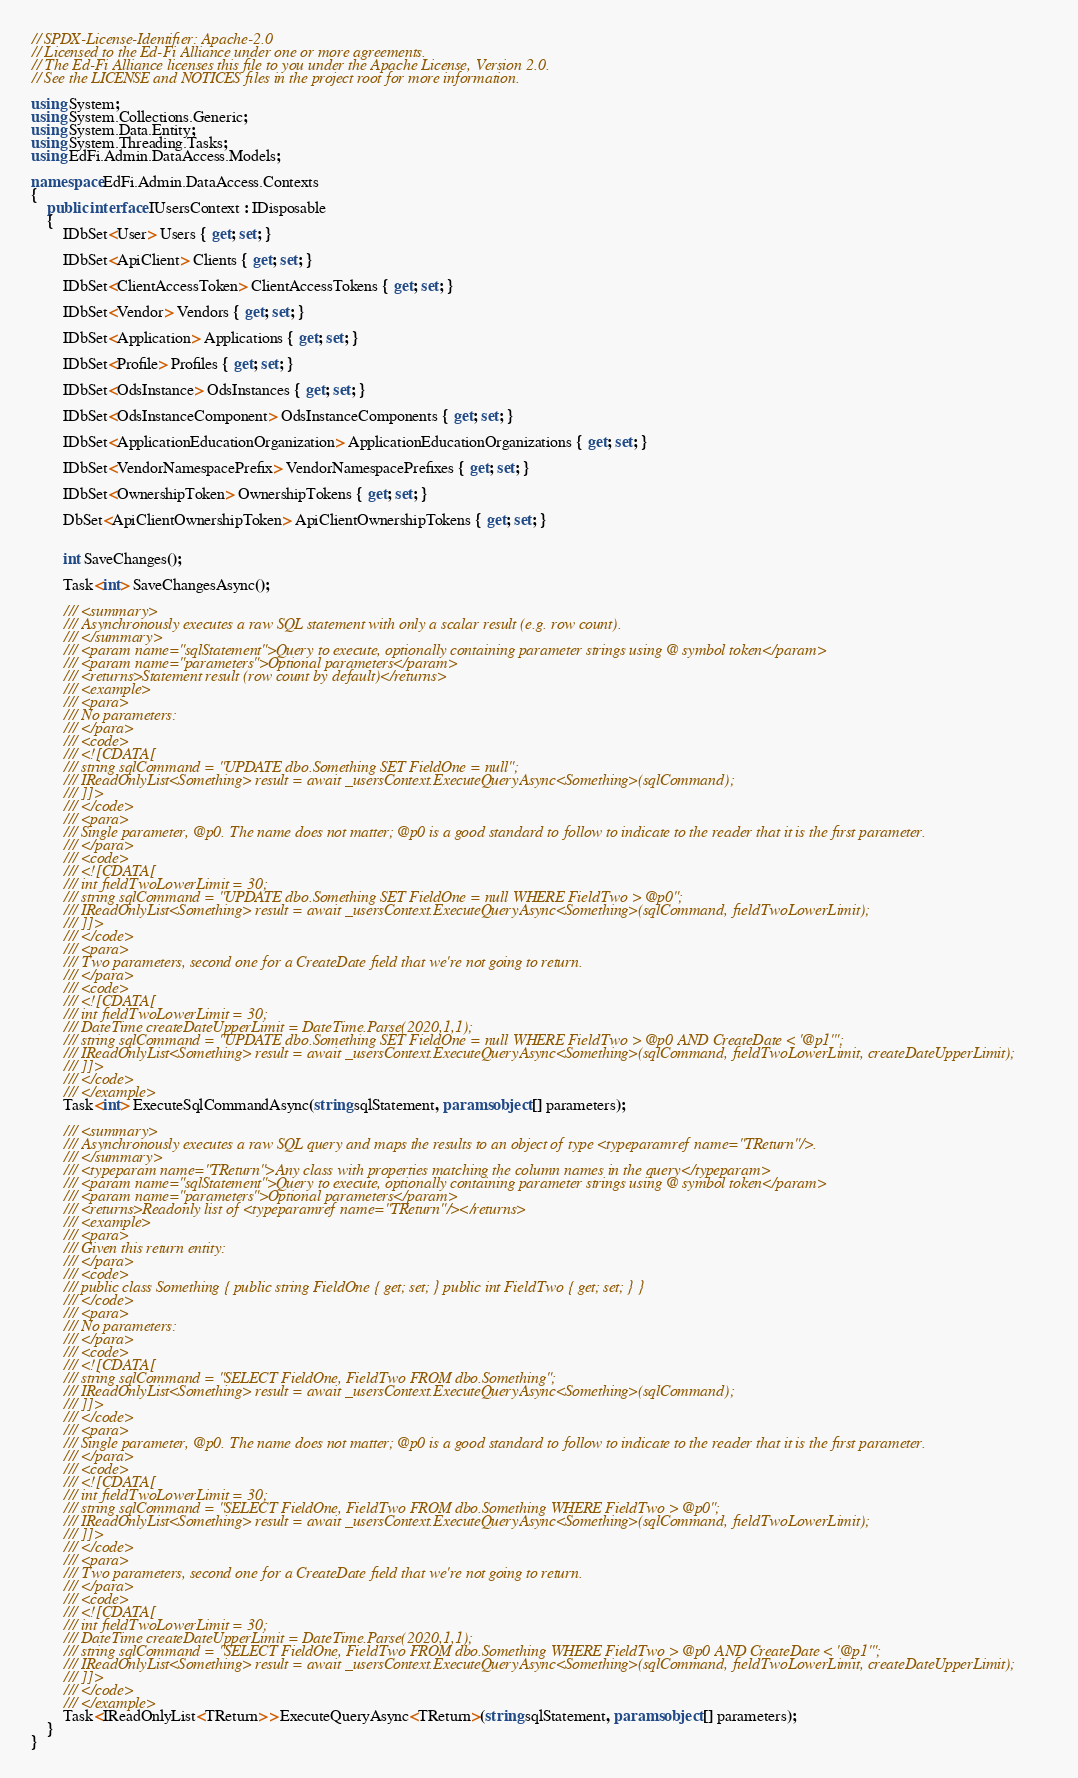Convert code to text. <code><loc_0><loc_0><loc_500><loc_500><_C#_>// SPDX-License-Identifier: Apache-2.0
// Licensed to the Ed-Fi Alliance under one or more agreements.
// The Ed-Fi Alliance licenses this file to you under the Apache License, Version 2.0.
// See the LICENSE and NOTICES files in the project root for more information.

using System;
using System.Collections.Generic;
using System.Data.Entity;
using System.Threading.Tasks;
using EdFi.Admin.DataAccess.Models;

namespace EdFi.Admin.DataAccess.Contexts
{
    public interface IUsersContext : IDisposable
    {
        IDbSet<User> Users { get; set; }

        IDbSet<ApiClient> Clients { get; set; }

        IDbSet<ClientAccessToken> ClientAccessTokens { get; set; }

        IDbSet<Vendor> Vendors { get; set; }

        IDbSet<Application> Applications { get; set; }

        IDbSet<Profile> Profiles { get; set; }

        IDbSet<OdsInstance> OdsInstances { get; set; }

        IDbSet<OdsInstanceComponent> OdsInstanceComponents { get; set; }

        IDbSet<ApplicationEducationOrganization> ApplicationEducationOrganizations { get; set; }

        IDbSet<VendorNamespacePrefix> VendorNamespacePrefixes { get; set; }

        IDbSet<OwnershipToken> OwnershipTokens { get; set; }

        DbSet<ApiClientOwnershipToken> ApiClientOwnershipTokens { get; set; }
        

        int SaveChanges();

        Task<int> SaveChangesAsync();

        /// <summary>
        /// Asynchronously executes a raw SQL statement with only a scalar result (e.g. row count).
        /// </summary>
        /// <param name="sqlStatement">Query to execute, optionally containing parameter strings using @ symbol token</param>
        /// <param name="parameters">Optional parameters</param>
        /// <returns>Statement result (row count by default)</returns>
        /// <example>
        /// <para>
        /// No parameters:
        /// </para>
        /// <code>
        /// <![CDATA[
        /// string sqlCommand = "UPDATE dbo.Something SET FieldOne = null";
        /// IReadOnlyList<Something> result = await _usersContext.ExecuteQueryAsync<Something>(sqlCommand);
        /// ]]>
        /// </code>
        /// <para>
        /// Single parameter, @p0. The name does not matter; @p0 is a good standard to follow to indicate to the reader that it is the first parameter.
        /// </para>
        /// <code>
        /// <![CDATA[
        /// int fieldTwoLowerLimit = 30;
        /// string sqlCommand = "UPDATE dbo.Something SET FieldOne = null WHERE FieldTwo > @p0";
        /// IReadOnlyList<Something> result = await _usersContext.ExecuteQueryAsync<Something>(sqlCommand, fieldTwoLowerLimit);
        /// ]]>
        /// </code>
        /// <para>
        /// Two parameters, second one for a CreateDate field that we're not going to return.
        /// </para>
        /// <code>
        /// <![CDATA[
        /// int fieldTwoLowerLimit = 30;
        /// DateTime createDateUpperLimit = DateTime.Parse(2020,1,1);
        /// string sqlCommand = "UPDATE dbo.Something SET FieldOne = null WHERE FieldTwo > @p0 AND CreateDate < '@p1'";
        /// IReadOnlyList<Something> result = await _usersContext.ExecuteQueryAsync<Something>(sqlCommand, fieldTwoLowerLimit, createDateUpperLimit);
        /// ]]>
        /// </code>
        /// </example>
        Task<int> ExecuteSqlCommandAsync(string sqlStatement, params object[] parameters);

        /// <summary>
        /// Asynchronously executes a raw SQL query and maps the results to an object of type <typeparamref name="TReturn"/>.
        /// </summary>
        /// <typeparam name="TReturn">Any class with properties matching the column names in the query</typeparam>
        /// <param name="sqlStatement">Query to execute, optionally containing parameter strings using @ symbol token</param>
        /// <param name="parameters">Optional parameters</param>
        /// <returns>Readonly list of <typeparamref name="TReturn"/></returns>
        /// <example>
        /// <para>
        /// Given this return entity:
        /// </para>
        /// <code>
        /// public class Something { public string FieldOne { get; set; } public int FieldTwo { get; set; } }
        /// </code>
        /// <para>
        /// No parameters:
        /// </para>
        /// <code>
        /// <![CDATA[
        /// string sqlCommand = "SELECT FieldOne, FieldTwo FROM dbo.Something";
        /// IReadOnlyList<Something> result = await _usersContext.ExecuteQueryAsync<Something>(sqlCommand);
        /// ]]>
        /// </code>
        /// <para>
        /// Single parameter, @p0. The name does not matter; @p0 is a good standard to follow to indicate to the reader that it is the first parameter.
        /// </para>
        /// <code>
        /// <![CDATA[
        /// int fieldTwoLowerLimit = 30;
        /// string sqlCommand = "SELECT FieldOne, FieldTwo FROM dbo.Something WHERE FieldTwo > @p0";
        /// IReadOnlyList<Something> result = await _usersContext.ExecuteQueryAsync<Something>(sqlCommand, fieldTwoLowerLimit);
        /// ]]>
        /// </code>
        /// <para>
        /// Two parameters, second one for a CreateDate field that we're not going to return.
        /// </para>
        /// <code>
        /// <![CDATA[
        /// int fieldTwoLowerLimit = 30;
        /// DateTime createDateUpperLimit = DateTime.Parse(2020,1,1);
        /// string sqlCommand = "SELECT FieldOne, FieldTwo FROM dbo.Something WHERE FieldTwo > @p0 AND CreateDate < '@p1'";
        /// IReadOnlyList<Something> result = await _usersContext.ExecuteQueryAsync<Something>(sqlCommand, fieldTwoLowerLimit, createDateUpperLimit);
        /// ]]>
        /// </code>
        /// </example>
        Task<IReadOnlyList<TReturn>> ExecuteQueryAsync<TReturn>(string sqlStatement, params object[] parameters);
    }
}
</code> 